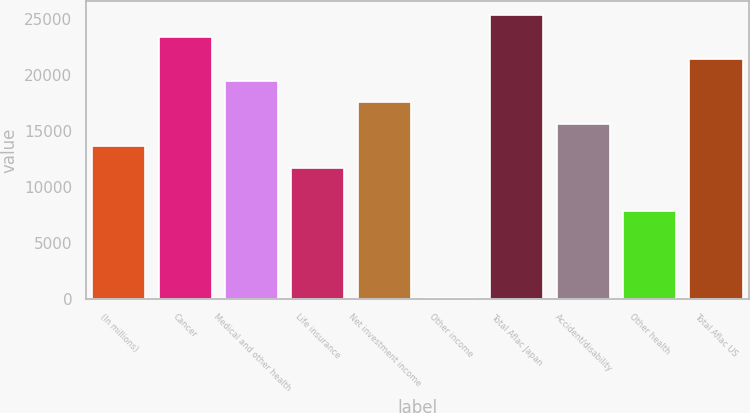Convert chart to OTSL. <chart><loc_0><loc_0><loc_500><loc_500><bar_chart><fcel>(In millions)<fcel>Cancer<fcel>Medical and other health<fcel>Life insurance<fcel>Net investment income<fcel>Other income<fcel>Total Aflac Japan<fcel>Accident/disability<fcel>Other health<fcel>Total Aflac US<nl><fcel>13655.9<fcel>23379.4<fcel>19490<fcel>11711.2<fcel>17545.3<fcel>43<fcel>25324.1<fcel>15600.6<fcel>7821.8<fcel>21434.7<nl></chart> 